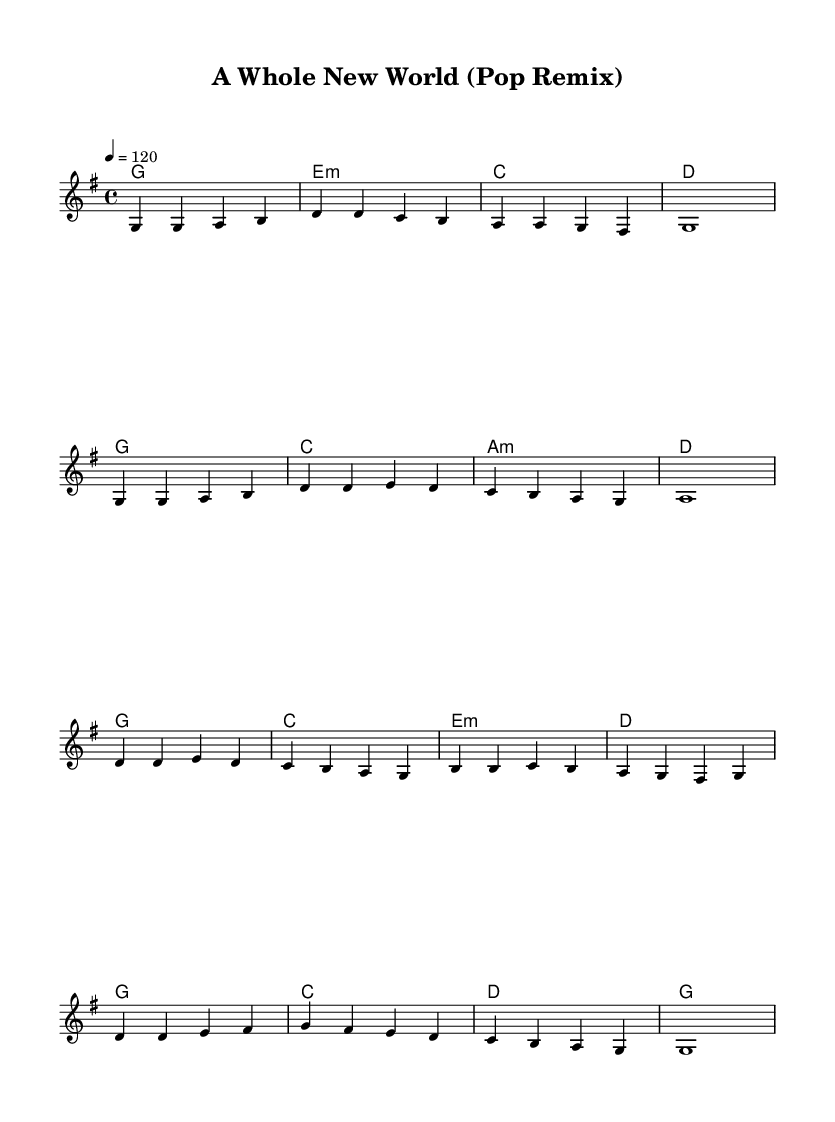What is the key signature of this music? The key signature is G major, which has one sharp, indicated by the F# in the staff.
Answer: G major What is the time signature of this music? The time signature is 4/4, which means there are four beats in each measure and the quarter note receives one beat.
Answer: 4/4 What is the tempo marking for this piece? The tempo marking is 120 beats per minute, indicated by the tempo of 4 = 120 at the beginning of the score.
Answer: 120 How many measures are there in the verse section? The verse section consists of eight measures, as counted from the beginning to where it transitions to the chorus.
Answer: 8 Which chord is used in the last measure of the chorus? The last measure of the chorus features the G major chord, as indicated in the harmonies section of the score.
Answer: G What is the melodic contour of the first three notes in the chorus? The first three notes in the chorus are descending: D, C, and B, indicating a downward movement in pitch.
Answer: Descending What type of arrangement does this piece exemplify in the context of Disney soundtracks? This piece exemplifies a pop remix arrangement, as it modernizes a classic Disney song with contemporary musical elements.
Answer: Pop remix 